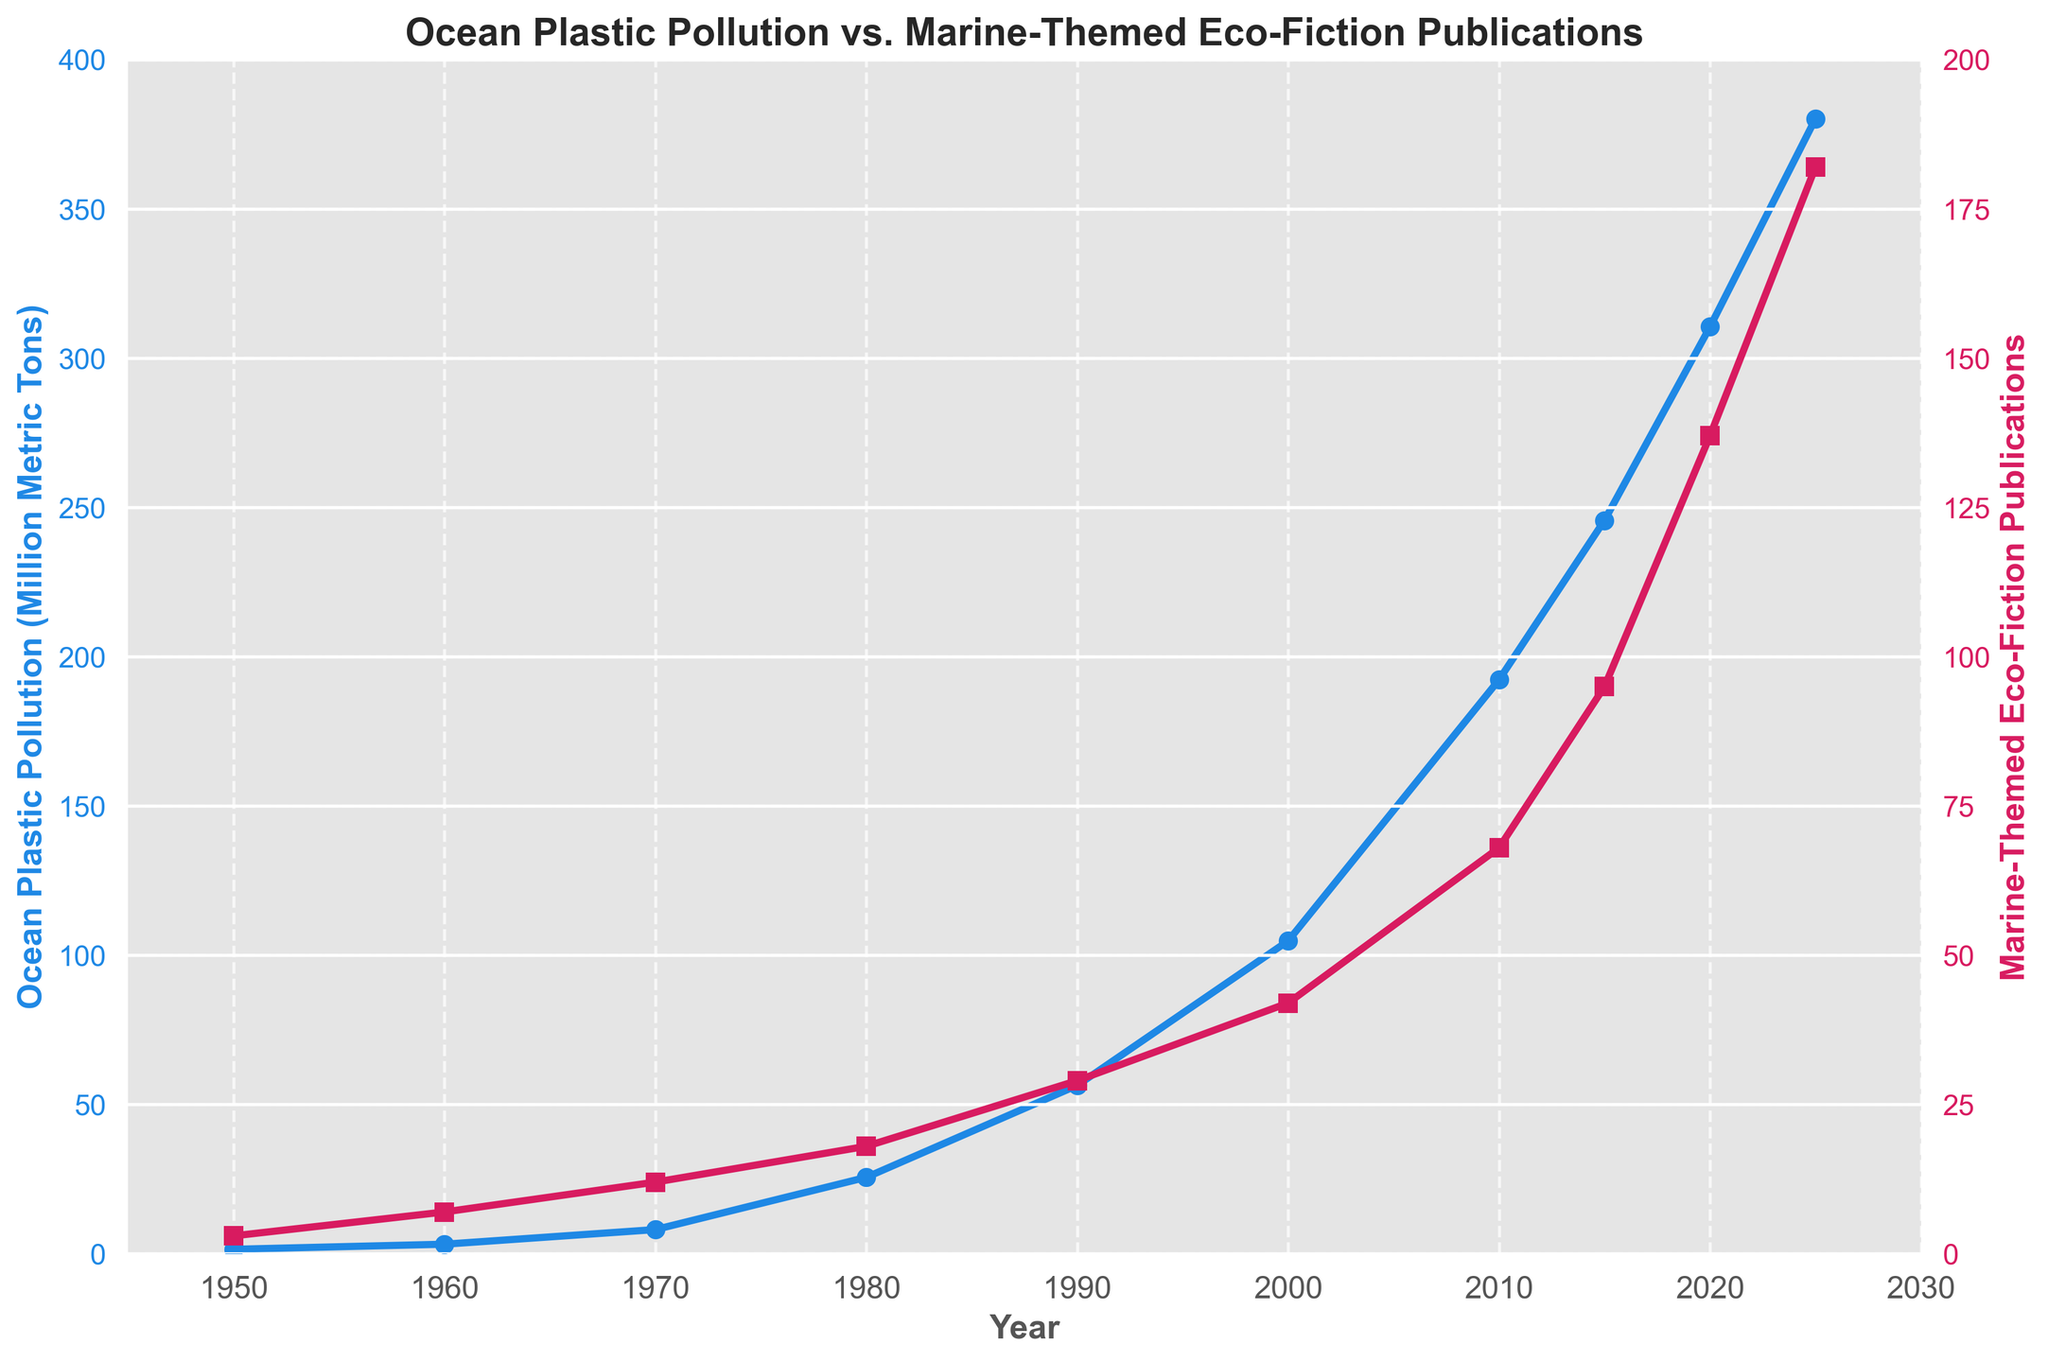What is the trend in ocean plastic pollution from 1950 to 2025? The trend in ocean plastic pollution shows a consistent and sharp increase from 1.5 million metric tons in 1950 to 380.2 million metric tons in 2025. This rise is exponential, indicating that ocean plastic pollution has been growing at an accelerating rate over the years.
Answer: Consistent increase Which year shows a more dramatic rise in marine-themed eco-fiction publications, 2000 or 2010? To find out which year shows a more dramatic rise, compare the difference in the number of publications between the two periods. In 2000, there are 42 publications, and in 2010, there are 68 publications. So the increase from 2000 to 2010 is 26.
Answer: 2010 What is the approximate rate of increase in ocean plastic pollution from 2010 to 2015? In 2010, ocean plastic pollution is 192.3 million metric tons, and in 2015, it is 245.7 million metric tons. The increase over this 5-year period is 245.7 - 192.3 = 53.4 million metric tons. Dividing by 5 years, the rate of increase is approximately 10.68 million metric tons per year.
Answer: 10.68 million metric tons per year Which variable shows a higher value in 2000, ocean plastic pollution or marine-themed eco-fiction publications? In 2000, ocean plastic pollution is at 104.8 million metric tons, while marine-themed eco-fiction publications are at 42. Comparing these values, ocean plastic pollution is higher.
Answer: Ocean plastic pollution Compare the number of marine-themed eco-fiction publications in 1970 and 1990. By how much did it increase? In 1970, there are 12 publications, and in 1990, there are 29 publications. The increase between these two years is 29 - 12 = 17.
Answer: 17 During which decade does the highest average annual increase in ocean plastic pollution occur? Calculate the increase for each decade: 1950-1960 (3.2 - 1.5 = 1.7), 1960-1970 (8.1 - 3.2 = 4.9), 1970-1980 (25.6 - 8.1 = 17.5), 1980-1990 (56.4 - 25.6 = 30.8), 1990-2000 (104.8 - 56.4 = 48.4), 2000-2010 (192.3 - 104.8 = 87.5), 2010-2020 (310.5 - 192.3 = 118.2). The highest increase occurs in 2010-2020 with 118.2 million metric tons. By dividing by 10 years, the average annual increase is 11.82 million metric tons per year.
Answer: 2010-2020 What is the correlation between ocean plastic pollution and marine-themed eco-fiction publications from 1950 to 2025 based on the trend in the graph? The trend shows that both ocean plastic pollution and marine-themed eco-fiction publications have been increasing exponentially over time, indicating a positive correlation. An increase in ocean plastic pollution is associated with an increase in marine-themed eco-fiction publications.
Answer: Positive correlation 